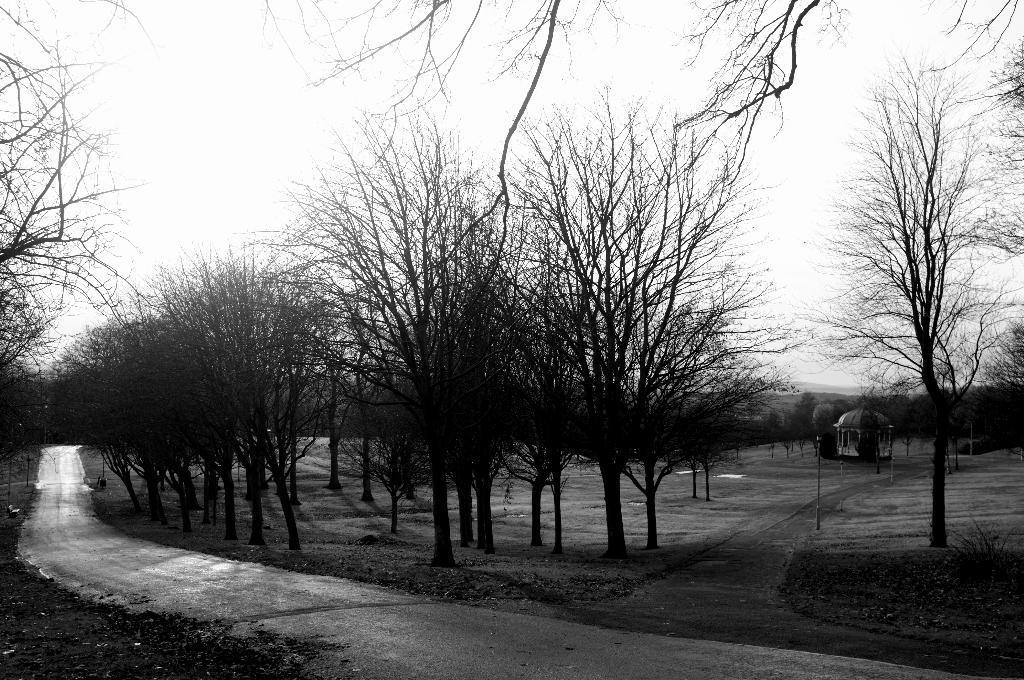In one or two sentences, can you explain what this image depicts? In this image we can see trees, sky, ground and a tomb like structure. 